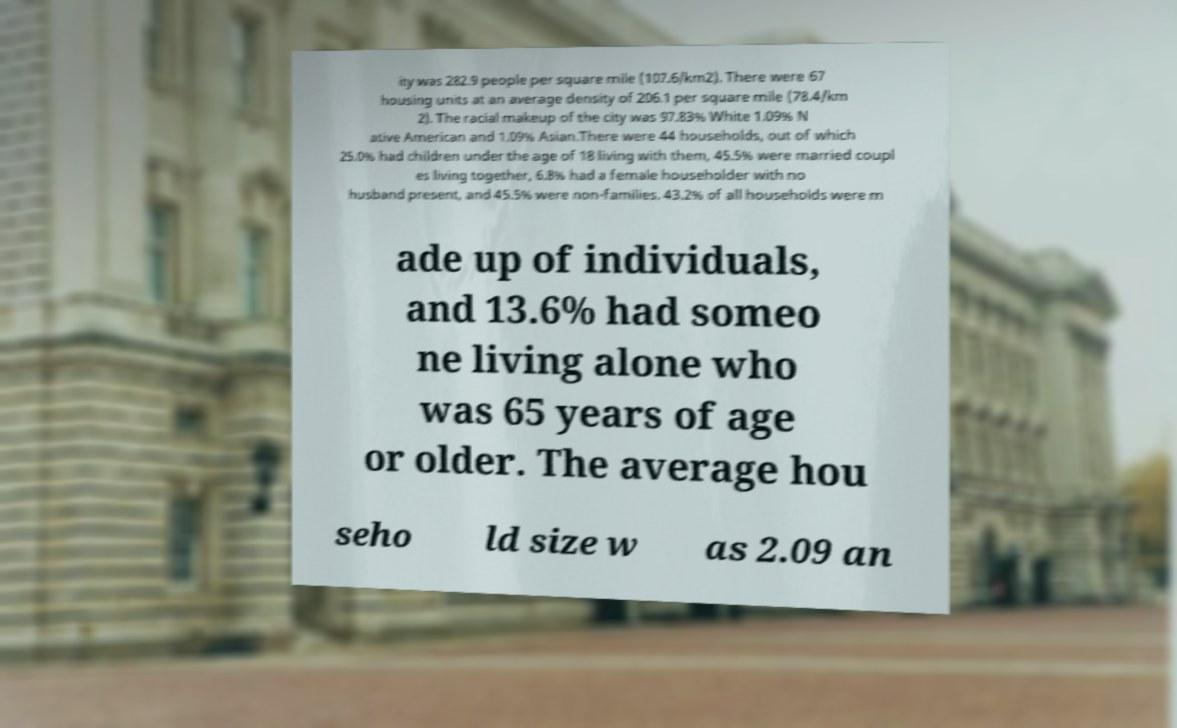Can you accurately transcribe the text from the provided image for me? ity was 282.9 people per square mile (107.6/km2). There were 67 housing units at an average density of 206.1 per square mile (78.4/km 2). The racial makeup of the city was 97.83% White 1.09% N ative American and 1.09% Asian.There were 44 households, out of which 25.0% had children under the age of 18 living with them, 45.5% were married coupl es living together, 6.8% had a female householder with no husband present, and 45.5% were non-families. 43.2% of all households were m ade up of individuals, and 13.6% had someo ne living alone who was 65 years of age or older. The average hou seho ld size w as 2.09 an 